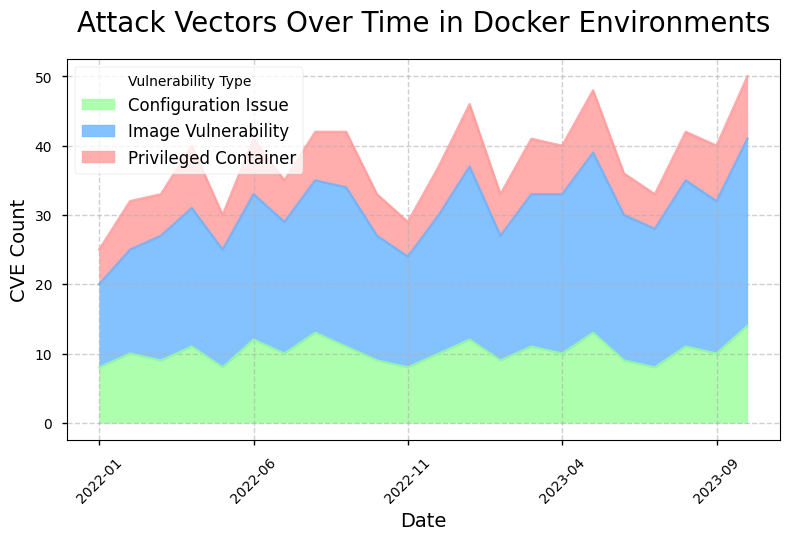What month had the highest total CVE count? To determine the month with the highest total CVE count, observe the height of each stacked area for each month and identify the tallest. This indicates the cumulative CVE counts for Privileged Container, Image Vulnerability, and Configuration Issues.
Answer: October 2023 Which month observed a decrease in the number of image vulnerabilities compared to the previous month? Compare the 'Image Vulnerability' area between consecutive months, looking for a downward step from one month to the next. In this context, the light blue area decreases from the previous month's value.
Answer: February 2023 What is the trend of Configuration Issues from January 2022 to October 2023? Observe the green-colored area representing 'Configuration Issue' over the given time period. Track its height to determine if it generally increases, decreases, or remains stable over time.
Answer: Increasing In which month was the number of privileged container vulnerabilities the highest? Identify the month with the highest peak in the red-colored area, which represents 'Privileged Container' vulnerabilities on the chart.
Answer: May 2023 How does the number of vulnerabilities in August 2023 compare to January 2022? Compare the combined heights of the stacked areas for both months. Check all sections for August 2023 and January 2022 to determine if the total is higher, lower, or equal in either month.
Answer: Higher in August 2023 What is the average monthly CVE count for Image Vulnerabilities from January 2023 to October 2023? Sum the counts of 'Image Vulnerability' from January 2023 to October 2023 and divide by the number of months (10). Calculate the average to find the monthly trend over this period. (25+18+22+23+26+21+20+24+22+27)/10.
Answer: 22.8 Which vulnerability type had the least variability over the given period? Compare all three types of vulnerabilities – Privileged Container, Image Vulnerability, and Configuration Issue – by observing the consistency in the respective colored areas' heights across the months. The one with the most uniform height over time had the least variability.
Answer: Configuration Issue Did the number of Configuration Issues ever surpass 12 in a single month? Examine the green-colored area to see if its peak height ever exceeds the mark indicating the CVE count of 12. Look specifically for taller peaks within the area.
Answer: Yes Which two consecutive months had the largest increase in Image Vulnerabilities? Observe the light blue areas representing 'Image Vulnerability' and identify where the height increased the most between two adjacent months. Compare the incremental differences to determine the largest jump.
Answer: December 2022 to January 2023 Comparing January 2022 and January 2023, what is the difference in the total CVE count? Sum the CVE counts for all three vulnerability types for January 2022 and January 2023, then subtract the former's total from the latter's total to find the difference. (5+12+8) for Jan 2022 and (9+25+12) for Jan 2023; Difference = (46) - (25).
Answer: 21 